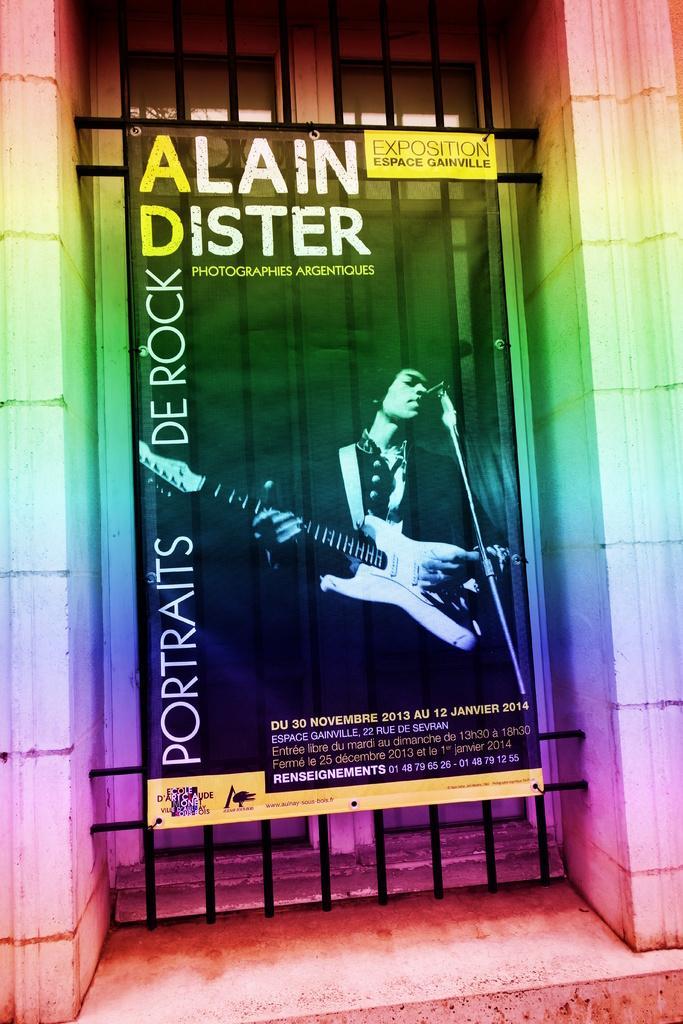Please provide a concise description of this image. In this image there is a poster attached to a metal rod frame. 